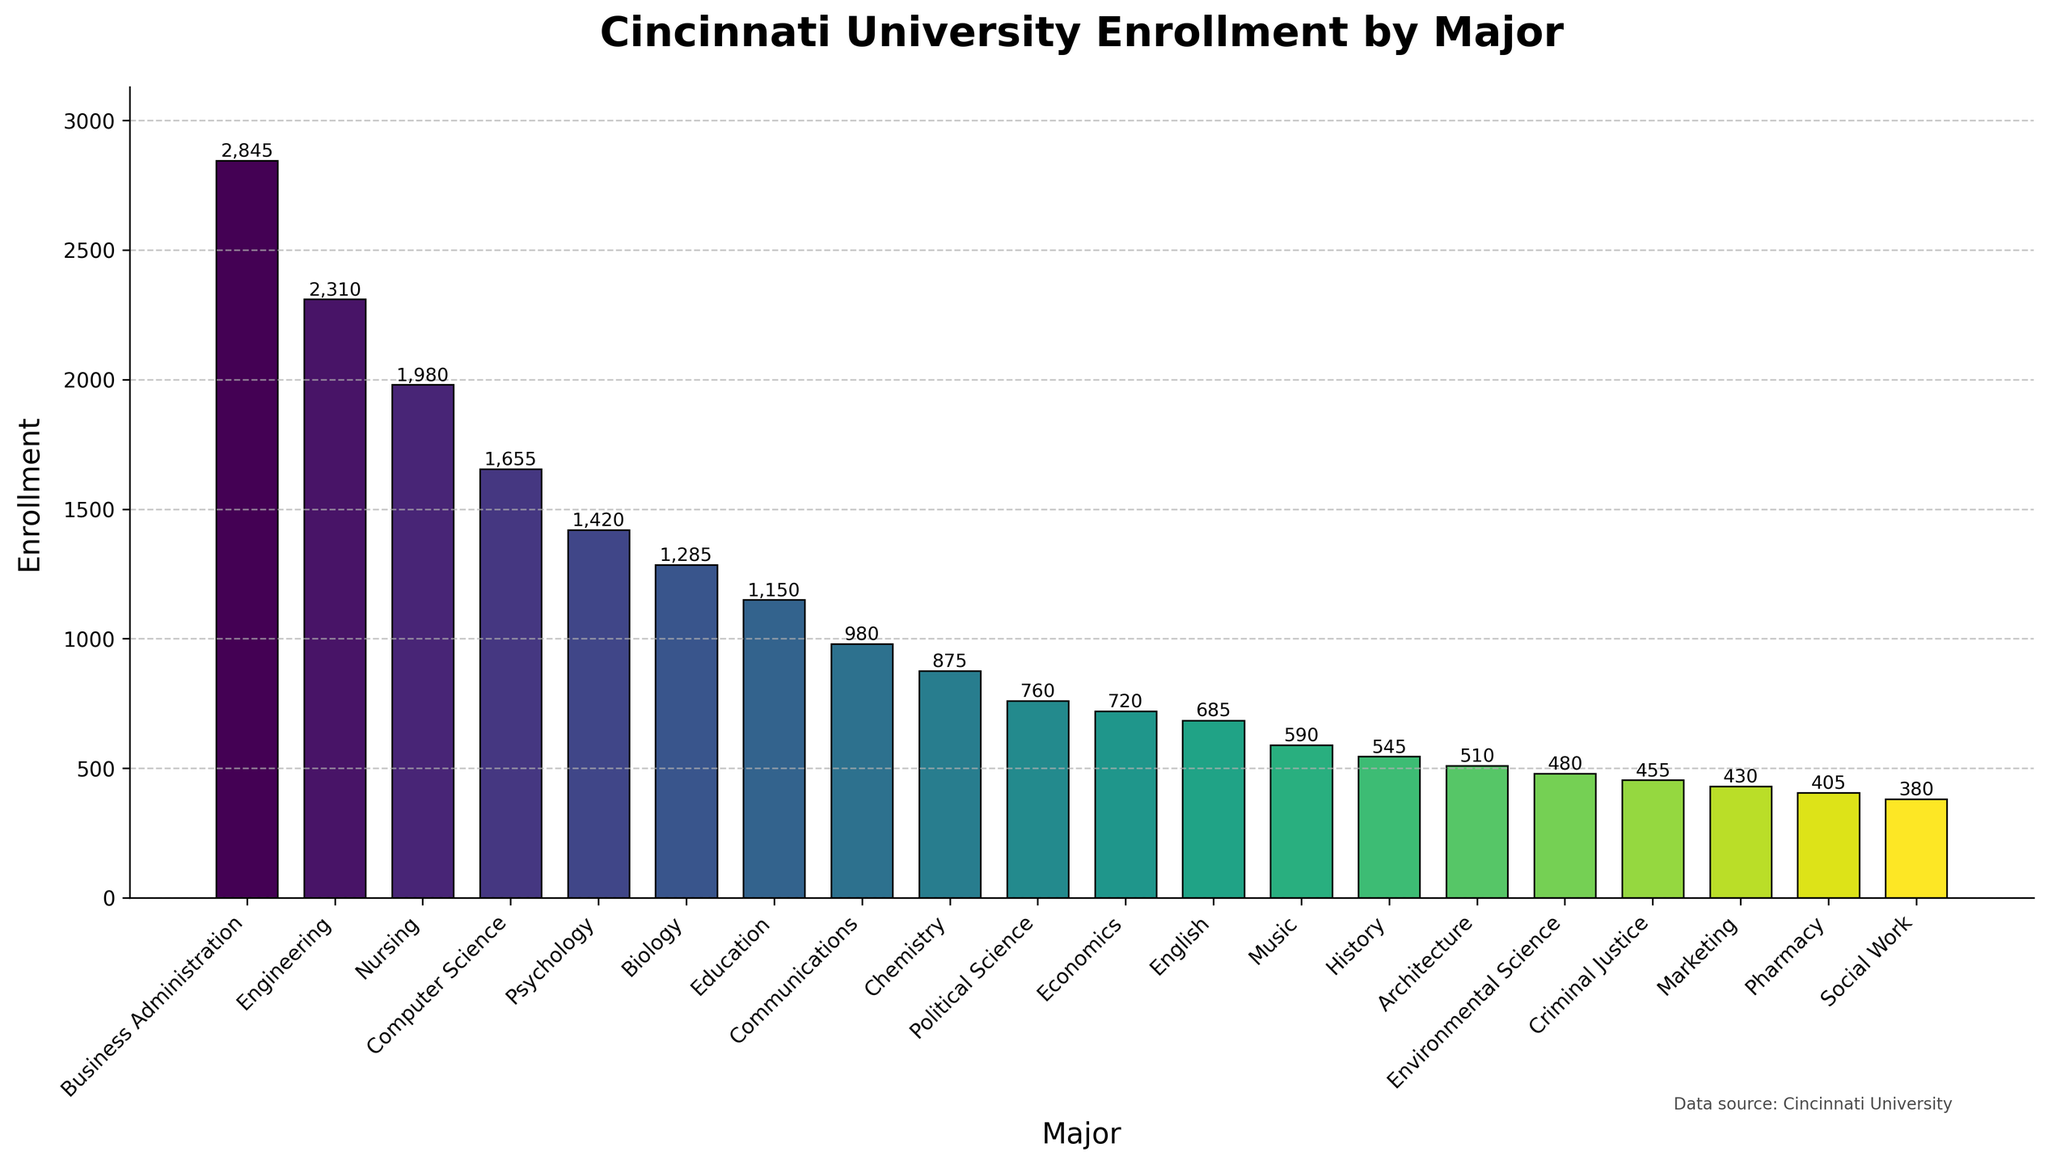What major has the highest enrollment? Find the bar with the greatest height and look at the labeled major. The highest enrollment is represented by the Business Administration major.
Answer: Business Administration Which major has the lowest enrollment? Identify the bar with the shortest height and note its labeled major. The lowest enrollment is indicated by the Social Work major.
Answer: Social Work What is the total enrollment for all majors combined? Sum the enrollments for all the majors: 2845 + 2310 + 1980 + 1655 + 1420 + 1285 + 1150 + 980 + 875 + 760 + 720 + 685 + 590 + 545 + 510 + 480 + 455 + 430 + 405 + 380 = 24,860.
Answer: 24,860 What is the average enrollment per major? Calculate the total enrollment (24,860) and divide by the number of majors (20). 24,860 / 20 = 1,243.
Answer: 1,243 How many more students are enrolled in Business Administration than in Architecture? Subtract the enrollment of Architecture from the enrollment of Business Administration: 2845 - 510 = 2335.
Answer: 2335 Which majors have an enrollment greater than 1000? Identify bars whose heights indicate enrollments greater than 1000. The majors are Business Administration (2845), Engineering (2310), Nursing (1980), Computer Science (1655), Psychology (1420), Biology (1285), and Education (1150).
Answer: Business Administration, Engineering, Nursing, Computer Science, Psychology, Biology, Education What is the difference in enrollment between Nursing and the combined enrollment of Music and History? Calculate the enrollment for Music and History together, 590 + 545 = 1135, and then subtract this from the enrollment for Nursing, 1980 - 1135 = 845.
Answer: 845 What is the median enrollment value of all majors? List all enrollments in ascending order: 380, 405, 430, 455, 480, 510, 545, 590, 685, 720, 760, 875, 980, 1150, 1285, 1420, 1655, 1980, 2310, 2845. The median is the average of the 10th and 11th values: (720 + 760) / 2 = 740.
Answer: 740 Compare the enrollment between Computer Science and Chemistry, which one has more students? Look at the heights of the bars labeled Computer Science (1655) and Chemistry (875) and compare them. Computer Science has more students.
Answer: Computer Science Calculate the percentage of total enrollment that is represented by Biology. First find the total enrollment (24,860), then the percentage is (1285 / 24,860) * 100 ≈ 5.17%.
Answer: ~5.17% 